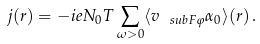Convert formula to latex. <formula><loc_0><loc_0><loc_500><loc_500>j ( r ) = - i e N _ { 0 } T \sum _ { \omega > 0 } \langle v _ { \ s u b F \varphi } \alpha _ { 0 } \rangle ( r ) \, .</formula> 